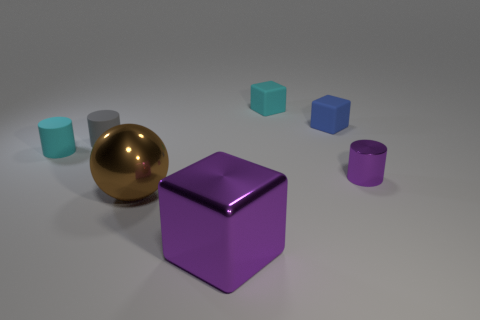The small shiny thing has what color? The small, shiny object in the image is gold in color, displaying a reflective surface that glimmers under the lighting of the scene. 